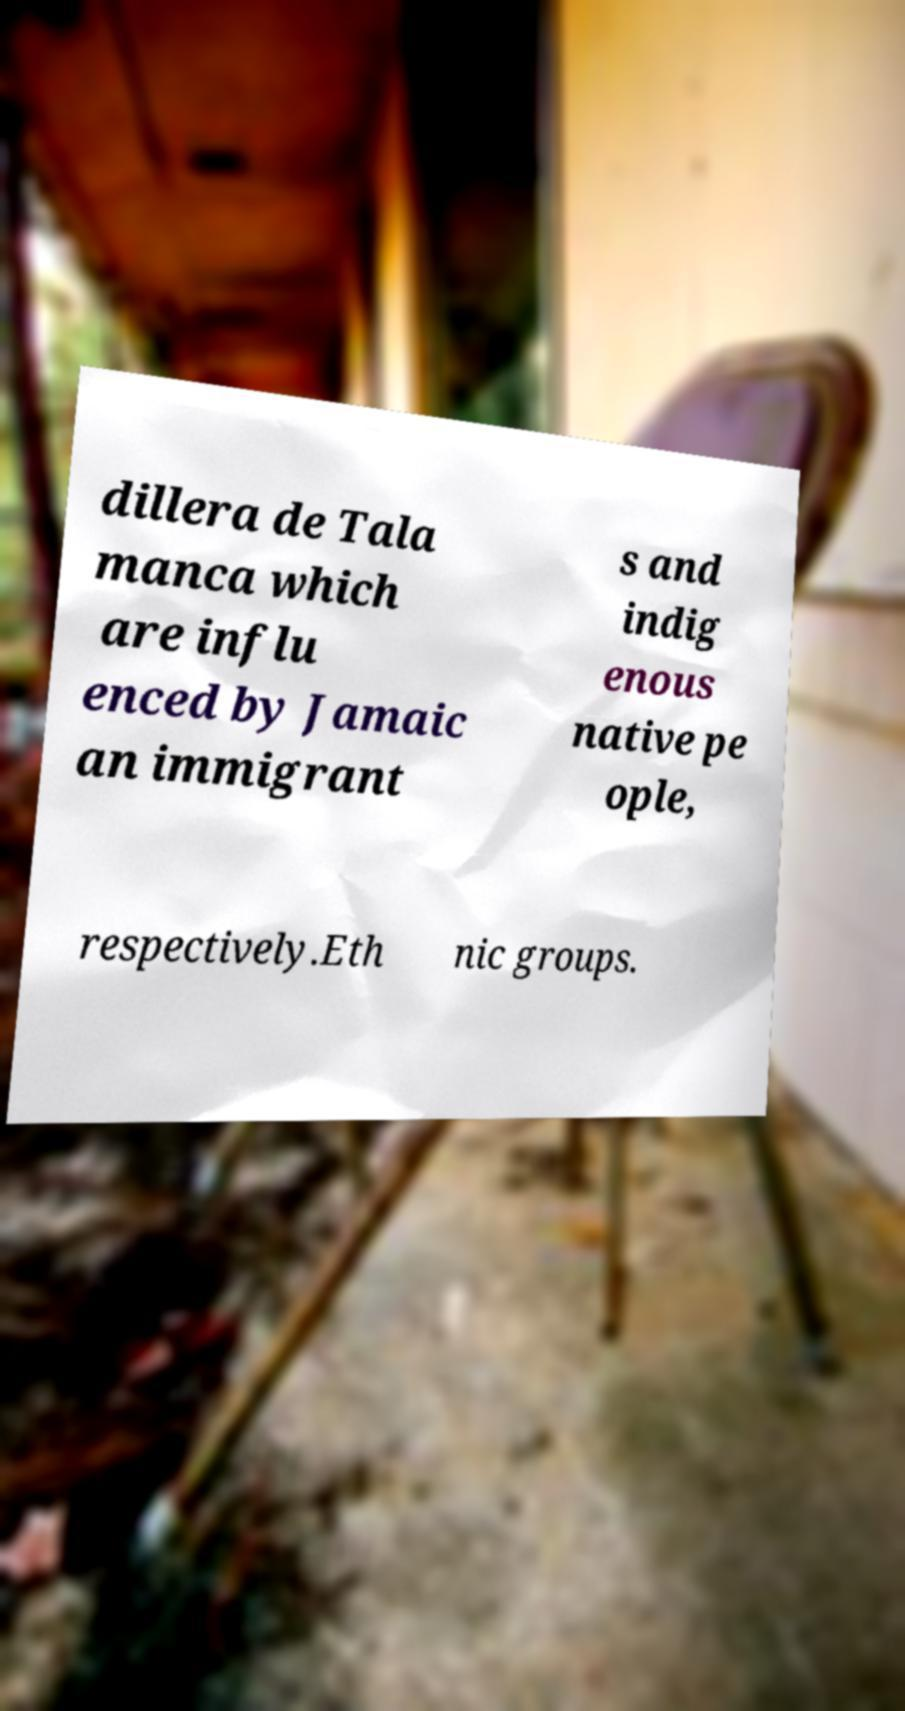Please read and relay the text visible in this image. What does it say? dillera de Tala manca which are influ enced by Jamaic an immigrant s and indig enous native pe ople, respectively.Eth nic groups. 